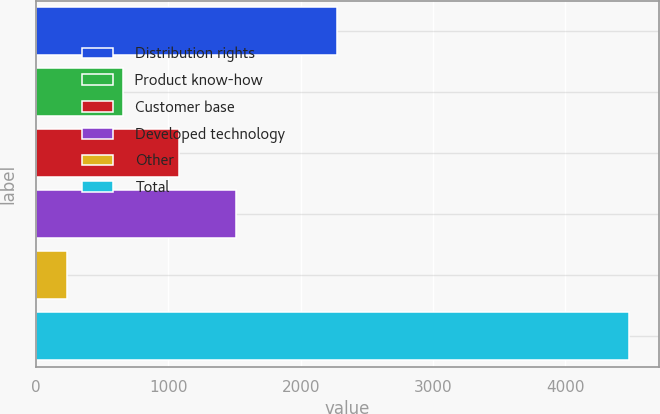Convert chart to OTSL. <chart><loc_0><loc_0><loc_500><loc_500><bar_chart><fcel>Distribution rights<fcel>Product know-how<fcel>Customer base<fcel>Developed technology<fcel>Other<fcel>Total<nl><fcel>2275<fcel>658<fcel>1083<fcel>1508<fcel>233<fcel>4483<nl></chart> 